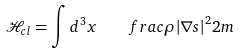Convert formula to latex. <formula><loc_0><loc_0><loc_500><loc_500>\mathcal { H } _ { c l } = \int d ^ { 3 } x \quad f r a c { \rho { \left | \nabla s \right | } ^ { 2 } } { 2 m }</formula> 